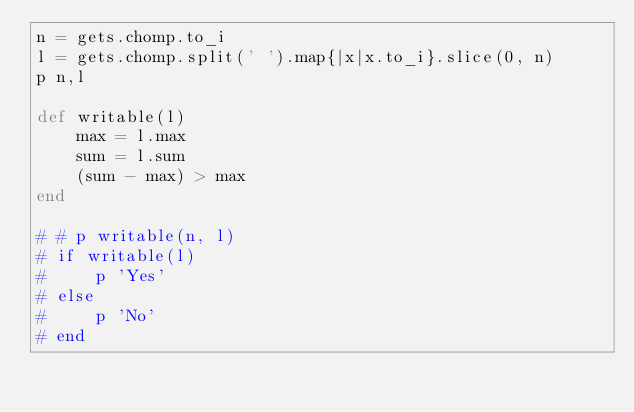Convert code to text. <code><loc_0><loc_0><loc_500><loc_500><_Ruby_>n = gets.chomp.to_i
l = gets.chomp.split(' ').map{|x|x.to_i}.slice(0, n)
p n,l

def writable(l)
    max = l.max
    sum = l.sum
    (sum - max) > max
end

# # p writable(n, l)
# if writable(l)
#     p 'Yes'
# else
#     p 'No'
# end</code> 